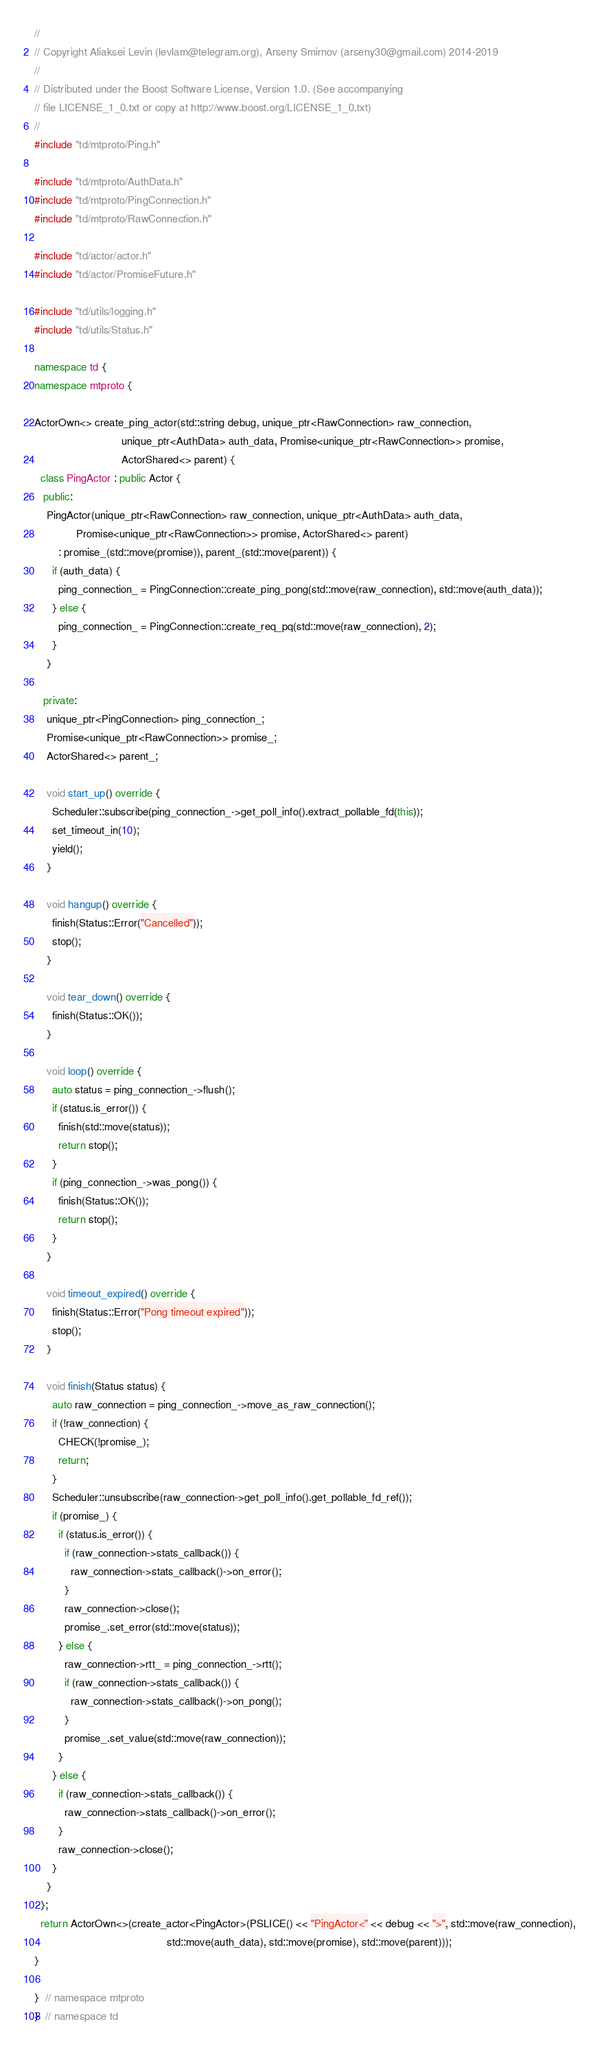<code> <loc_0><loc_0><loc_500><loc_500><_C++_>//
// Copyright Aliaksei Levin (levlam@telegram.org), Arseny Smirnov (arseny30@gmail.com) 2014-2019
//
// Distributed under the Boost Software License, Version 1.0. (See accompanying
// file LICENSE_1_0.txt or copy at http://www.boost.org/LICENSE_1_0.txt)
//
#include "td/mtproto/Ping.h"

#include "td/mtproto/AuthData.h"
#include "td/mtproto/PingConnection.h"
#include "td/mtproto/RawConnection.h"

#include "td/actor/actor.h"
#include "td/actor/PromiseFuture.h"

#include "td/utils/logging.h"
#include "td/utils/Status.h"

namespace td {
namespace mtproto {

ActorOwn<> create_ping_actor(std::string debug, unique_ptr<RawConnection> raw_connection,
                             unique_ptr<AuthData> auth_data, Promise<unique_ptr<RawConnection>> promise,
                             ActorShared<> parent) {
  class PingActor : public Actor {
   public:
    PingActor(unique_ptr<RawConnection> raw_connection, unique_ptr<AuthData> auth_data,
              Promise<unique_ptr<RawConnection>> promise, ActorShared<> parent)
        : promise_(std::move(promise)), parent_(std::move(parent)) {
      if (auth_data) {
        ping_connection_ = PingConnection::create_ping_pong(std::move(raw_connection), std::move(auth_data));
      } else {
        ping_connection_ = PingConnection::create_req_pq(std::move(raw_connection), 2);
      }
    }

   private:
    unique_ptr<PingConnection> ping_connection_;
    Promise<unique_ptr<RawConnection>> promise_;
    ActorShared<> parent_;

    void start_up() override {
      Scheduler::subscribe(ping_connection_->get_poll_info().extract_pollable_fd(this));
      set_timeout_in(10);
      yield();
    }

    void hangup() override {
      finish(Status::Error("Cancelled"));
      stop();
    }

    void tear_down() override {
      finish(Status::OK());
    }

    void loop() override {
      auto status = ping_connection_->flush();
      if (status.is_error()) {
        finish(std::move(status));
        return stop();
      }
      if (ping_connection_->was_pong()) {
        finish(Status::OK());
        return stop();
      }
    }

    void timeout_expired() override {
      finish(Status::Error("Pong timeout expired"));
      stop();
    }

    void finish(Status status) {
      auto raw_connection = ping_connection_->move_as_raw_connection();
      if (!raw_connection) {
        CHECK(!promise_);
        return;
      }
      Scheduler::unsubscribe(raw_connection->get_poll_info().get_pollable_fd_ref());
      if (promise_) {
        if (status.is_error()) {
          if (raw_connection->stats_callback()) {
            raw_connection->stats_callback()->on_error();
          }
          raw_connection->close();
          promise_.set_error(std::move(status));
        } else {
          raw_connection->rtt_ = ping_connection_->rtt();
          if (raw_connection->stats_callback()) {
            raw_connection->stats_callback()->on_pong();
          }
          promise_.set_value(std::move(raw_connection));
        }
      } else {
        if (raw_connection->stats_callback()) {
          raw_connection->stats_callback()->on_error();
        }
        raw_connection->close();
      }
    }
  };
  return ActorOwn<>(create_actor<PingActor>(PSLICE() << "PingActor<" << debug << ">", std::move(raw_connection),
                                            std::move(auth_data), std::move(promise), std::move(parent)));
}

}  // namespace mtproto
}  // namespace td
</code> 